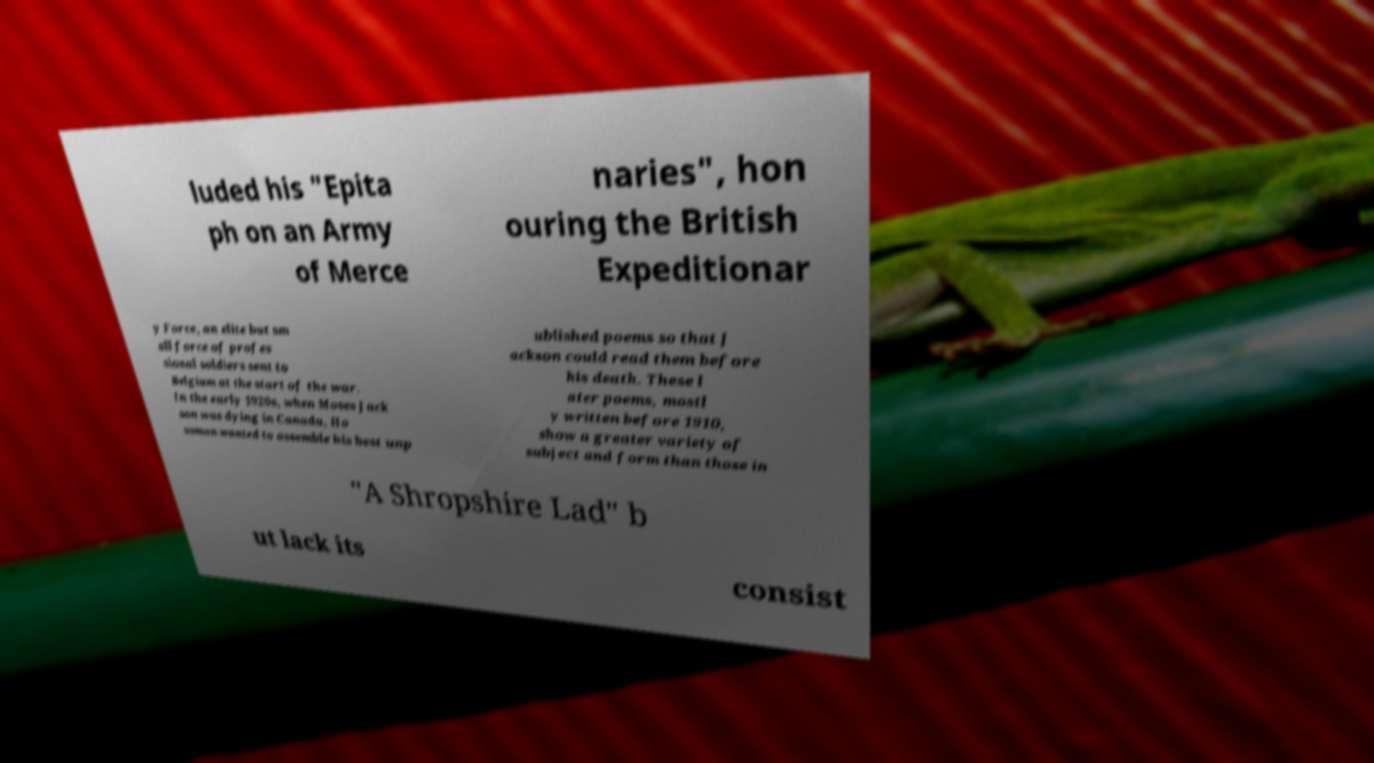For documentation purposes, I need the text within this image transcribed. Could you provide that? luded his "Epita ph on an Army of Merce naries", hon ouring the British Expeditionar y Force, an elite but sm all force of profes sional soldiers sent to Belgium at the start of the war. In the early 1920s, when Moses Jack son was dying in Canada, Ho usman wanted to assemble his best unp ublished poems so that J ackson could read them before his death. These l ater poems, mostl y written before 1910, show a greater variety of subject and form than those in "A Shropshire Lad" b ut lack its consist 